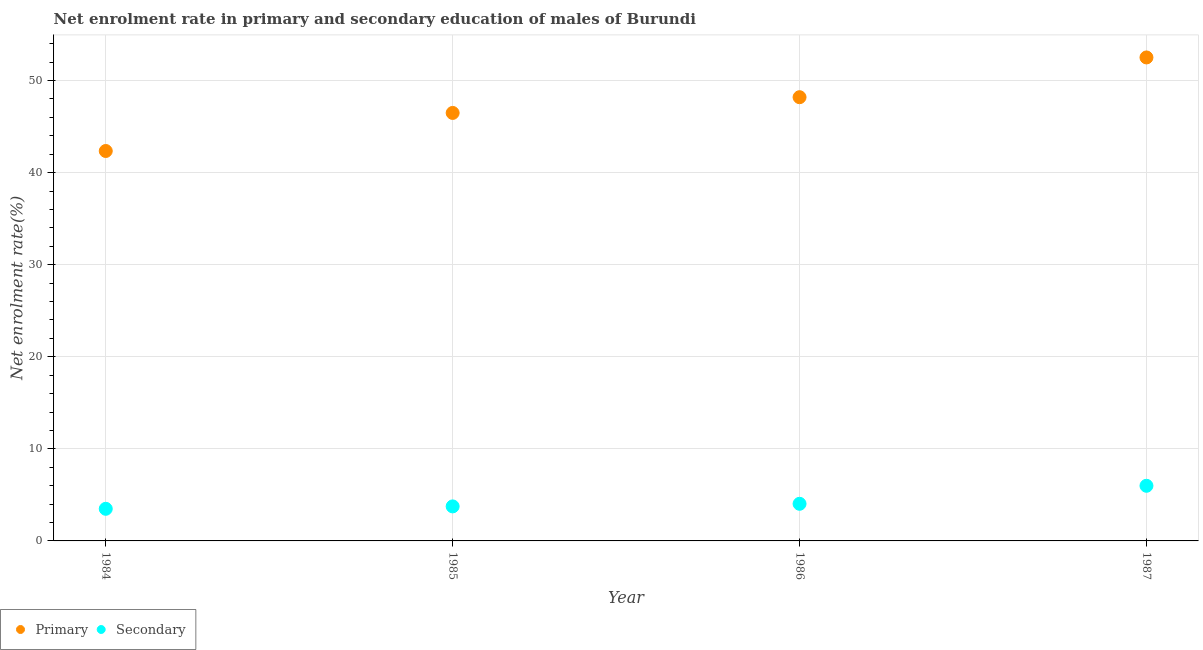Is the number of dotlines equal to the number of legend labels?
Your answer should be compact. Yes. What is the enrollment rate in secondary education in 1986?
Your answer should be compact. 4.03. Across all years, what is the maximum enrollment rate in primary education?
Give a very brief answer. 52.51. Across all years, what is the minimum enrollment rate in secondary education?
Keep it short and to the point. 3.49. In which year was the enrollment rate in primary education minimum?
Your answer should be very brief. 1984. What is the total enrollment rate in primary education in the graph?
Offer a terse response. 189.52. What is the difference between the enrollment rate in primary education in 1985 and that in 1986?
Offer a terse response. -1.71. What is the difference between the enrollment rate in primary education in 1985 and the enrollment rate in secondary education in 1984?
Give a very brief answer. 42.99. What is the average enrollment rate in primary education per year?
Your answer should be compact. 47.38. In the year 1986, what is the difference between the enrollment rate in primary education and enrollment rate in secondary education?
Make the answer very short. 44.16. What is the ratio of the enrollment rate in primary education in 1985 to that in 1986?
Your answer should be compact. 0.96. Is the enrollment rate in secondary education in 1986 less than that in 1987?
Ensure brevity in your answer.  Yes. Is the difference between the enrollment rate in primary education in 1985 and 1987 greater than the difference between the enrollment rate in secondary education in 1985 and 1987?
Offer a very short reply. No. What is the difference between the highest and the second highest enrollment rate in primary education?
Your answer should be very brief. 4.32. What is the difference between the highest and the lowest enrollment rate in secondary education?
Your answer should be compact. 2.5. Is the sum of the enrollment rate in primary education in 1985 and 1987 greater than the maximum enrollment rate in secondary education across all years?
Your answer should be compact. Yes. Does the enrollment rate in primary education monotonically increase over the years?
Make the answer very short. Yes. Is the enrollment rate in secondary education strictly greater than the enrollment rate in primary education over the years?
Your answer should be compact. No. Is the enrollment rate in secondary education strictly less than the enrollment rate in primary education over the years?
Make the answer very short. Yes. Are the values on the major ticks of Y-axis written in scientific E-notation?
Offer a very short reply. No. How many legend labels are there?
Your response must be concise. 2. How are the legend labels stacked?
Your answer should be compact. Horizontal. What is the title of the graph?
Give a very brief answer. Net enrolment rate in primary and secondary education of males of Burundi. What is the label or title of the X-axis?
Your response must be concise. Year. What is the label or title of the Y-axis?
Your response must be concise. Net enrolment rate(%). What is the Net enrolment rate(%) in Primary in 1984?
Make the answer very short. 42.35. What is the Net enrolment rate(%) in Secondary in 1984?
Give a very brief answer. 3.49. What is the Net enrolment rate(%) of Primary in 1985?
Your response must be concise. 46.48. What is the Net enrolment rate(%) in Secondary in 1985?
Your response must be concise. 3.75. What is the Net enrolment rate(%) in Primary in 1986?
Your response must be concise. 48.19. What is the Net enrolment rate(%) in Secondary in 1986?
Provide a succinct answer. 4.03. What is the Net enrolment rate(%) of Primary in 1987?
Your response must be concise. 52.51. What is the Net enrolment rate(%) in Secondary in 1987?
Give a very brief answer. 5.99. Across all years, what is the maximum Net enrolment rate(%) of Primary?
Offer a terse response. 52.51. Across all years, what is the maximum Net enrolment rate(%) of Secondary?
Offer a very short reply. 5.99. Across all years, what is the minimum Net enrolment rate(%) in Primary?
Your answer should be compact. 42.35. Across all years, what is the minimum Net enrolment rate(%) in Secondary?
Your answer should be very brief. 3.49. What is the total Net enrolment rate(%) in Primary in the graph?
Your response must be concise. 189.52. What is the total Net enrolment rate(%) of Secondary in the graph?
Make the answer very short. 17.26. What is the difference between the Net enrolment rate(%) in Primary in 1984 and that in 1985?
Ensure brevity in your answer.  -4.13. What is the difference between the Net enrolment rate(%) in Secondary in 1984 and that in 1985?
Offer a very short reply. -0.26. What is the difference between the Net enrolment rate(%) in Primary in 1984 and that in 1986?
Your answer should be very brief. -5.84. What is the difference between the Net enrolment rate(%) in Secondary in 1984 and that in 1986?
Make the answer very short. -0.54. What is the difference between the Net enrolment rate(%) in Primary in 1984 and that in 1987?
Your answer should be compact. -10.16. What is the difference between the Net enrolment rate(%) of Secondary in 1984 and that in 1987?
Keep it short and to the point. -2.5. What is the difference between the Net enrolment rate(%) in Primary in 1985 and that in 1986?
Give a very brief answer. -1.71. What is the difference between the Net enrolment rate(%) in Secondary in 1985 and that in 1986?
Keep it short and to the point. -0.28. What is the difference between the Net enrolment rate(%) in Primary in 1985 and that in 1987?
Your answer should be compact. -6.03. What is the difference between the Net enrolment rate(%) in Secondary in 1985 and that in 1987?
Give a very brief answer. -2.24. What is the difference between the Net enrolment rate(%) of Primary in 1986 and that in 1987?
Give a very brief answer. -4.32. What is the difference between the Net enrolment rate(%) in Secondary in 1986 and that in 1987?
Your response must be concise. -1.96. What is the difference between the Net enrolment rate(%) in Primary in 1984 and the Net enrolment rate(%) in Secondary in 1985?
Offer a very short reply. 38.6. What is the difference between the Net enrolment rate(%) of Primary in 1984 and the Net enrolment rate(%) of Secondary in 1986?
Offer a terse response. 38.31. What is the difference between the Net enrolment rate(%) of Primary in 1984 and the Net enrolment rate(%) of Secondary in 1987?
Offer a very short reply. 36.36. What is the difference between the Net enrolment rate(%) in Primary in 1985 and the Net enrolment rate(%) in Secondary in 1986?
Provide a succinct answer. 42.45. What is the difference between the Net enrolment rate(%) of Primary in 1985 and the Net enrolment rate(%) of Secondary in 1987?
Offer a terse response. 40.49. What is the difference between the Net enrolment rate(%) in Primary in 1986 and the Net enrolment rate(%) in Secondary in 1987?
Offer a very short reply. 42.2. What is the average Net enrolment rate(%) of Primary per year?
Give a very brief answer. 47.38. What is the average Net enrolment rate(%) in Secondary per year?
Your response must be concise. 4.31. In the year 1984, what is the difference between the Net enrolment rate(%) of Primary and Net enrolment rate(%) of Secondary?
Offer a terse response. 38.86. In the year 1985, what is the difference between the Net enrolment rate(%) of Primary and Net enrolment rate(%) of Secondary?
Ensure brevity in your answer.  42.73. In the year 1986, what is the difference between the Net enrolment rate(%) in Primary and Net enrolment rate(%) in Secondary?
Keep it short and to the point. 44.16. In the year 1987, what is the difference between the Net enrolment rate(%) of Primary and Net enrolment rate(%) of Secondary?
Your answer should be compact. 46.52. What is the ratio of the Net enrolment rate(%) in Primary in 1984 to that in 1985?
Your answer should be very brief. 0.91. What is the ratio of the Net enrolment rate(%) of Secondary in 1984 to that in 1985?
Give a very brief answer. 0.93. What is the ratio of the Net enrolment rate(%) in Primary in 1984 to that in 1986?
Ensure brevity in your answer.  0.88. What is the ratio of the Net enrolment rate(%) in Secondary in 1984 to that in 1986?
Provide a succinct answer. 0.87. What is the ratio of the Net enrolment rate(%) of Primary in 1984 to that in 1987?
Your answer should be compact. 0.81. What is the ratio of the Net enrolment rate(%) of Secondary in 1984 to that in 1987?
Ensure brevity in your answer.  0.58. What is the ratio of the Net enrolment rate(%) of Primary in 1985 to that in 1986?
Provide a short and direct response. 0.96. What is the ratio of the Net enrolment rate(%) of Secondary in 1985 to that in 1986?
Provide a short and direct response. 0.93. What is the ratio of the Net enrolment rate(%) in Primary in 1985 to that in 1987?
Offer a very short reply. 0.89. What is the ratio of the Net enrolment rate(%) of Secondary in 1985 to that in 1987?
Your answer should be very brief. 0.63. What is the ratio of the Net enrolment rate(%) of Primary in 1986 to that in 1987?
Give a very brief answer. 0.92. What is the ratio of the Net enrolment rate(%) of Secondary in 1986 to that in 1987?
Provide a short and direct response. 0.67. What is the difference between the highest and the second highest Net enrolment rate(%) in Primary?
Offer a terse response. 4.32. What is the difference between the highest and the second highest Net enrolment rate(%) of Secondary?
Provide a short and direct response. 1.96. What is the difference between the highest and the lowest Net enrolment rate(%) in Primary?
Provide a short and direct response. 10.16. What is the difference between the highest and the lowest Net enrolment rate(%) of Secondary?
Keep it short and to the point. 2.5. 